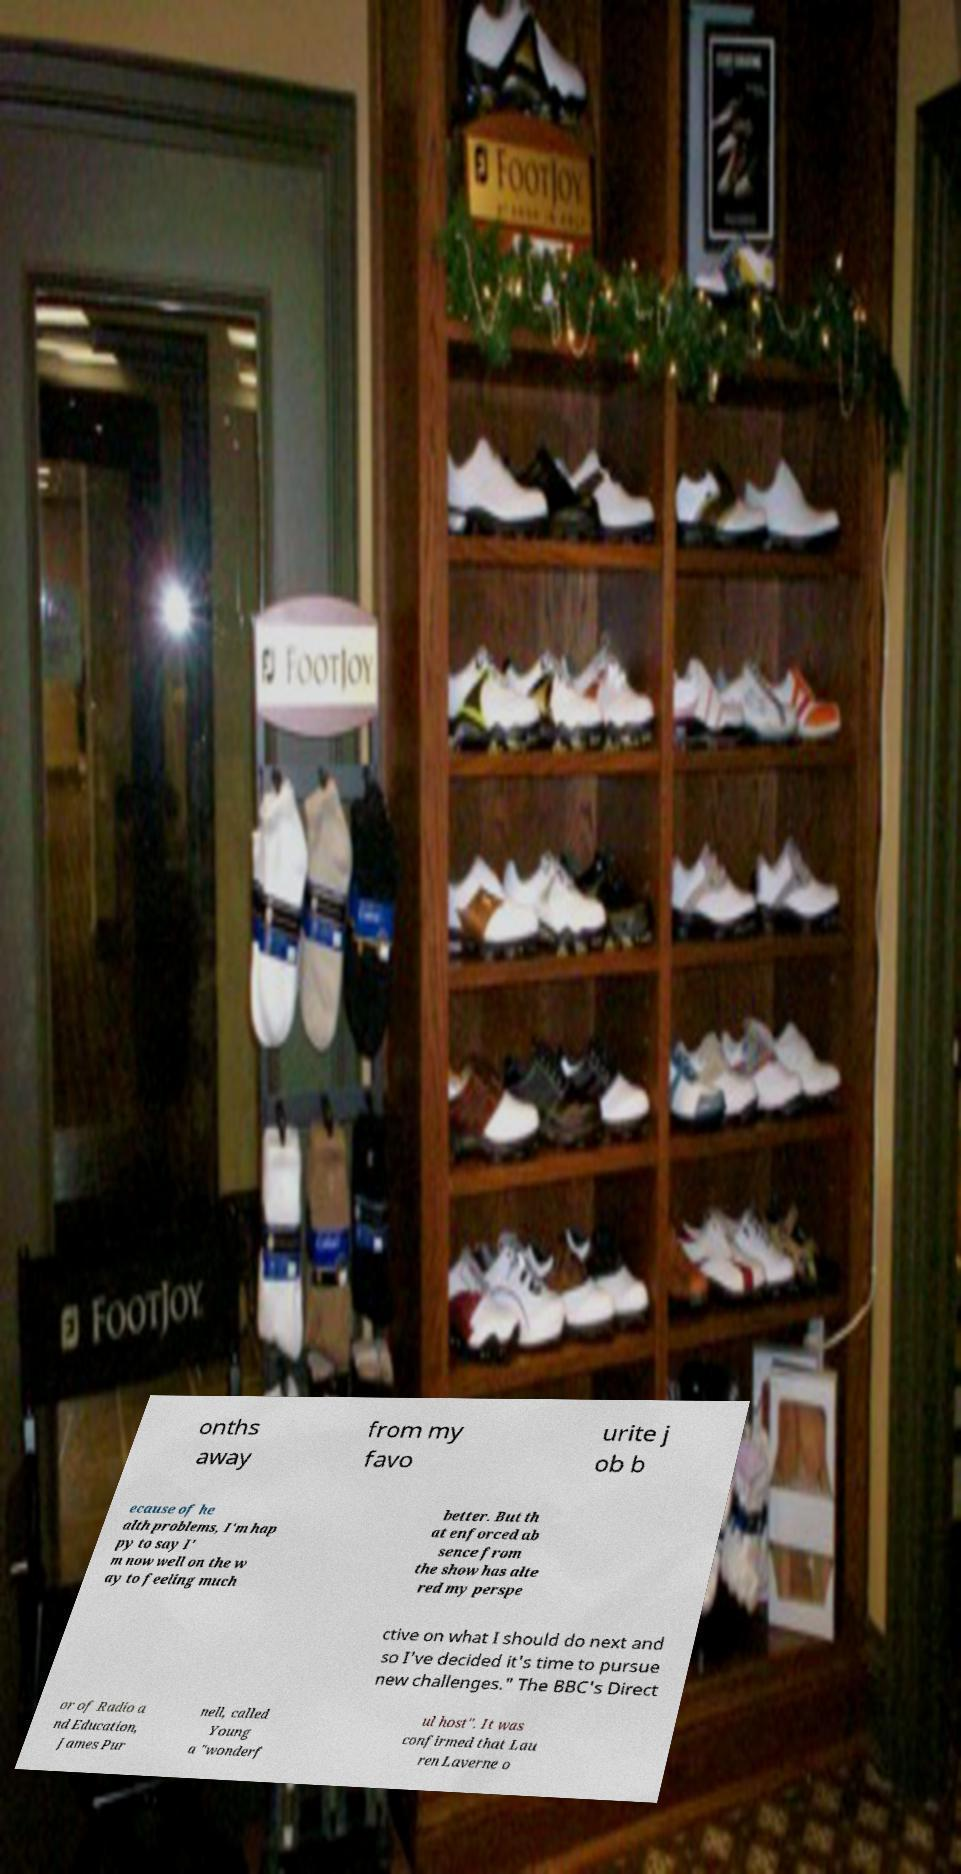Could you extract and type out the text from this image? onths away from my favo urite j ob b ecause of he alth problems, I'm hap py to say I' m now well on the w ay to feeling much better. But th at enforced ab sence from the show has alte red my perspe ctive on what I should do next and so I've decided it's time to pursue new challenges." The BBC's Direct or of Radio a nd Education, James Pur nell, called Young a "wonderf ul host". It was confirmed that Lau ren Laverne o 